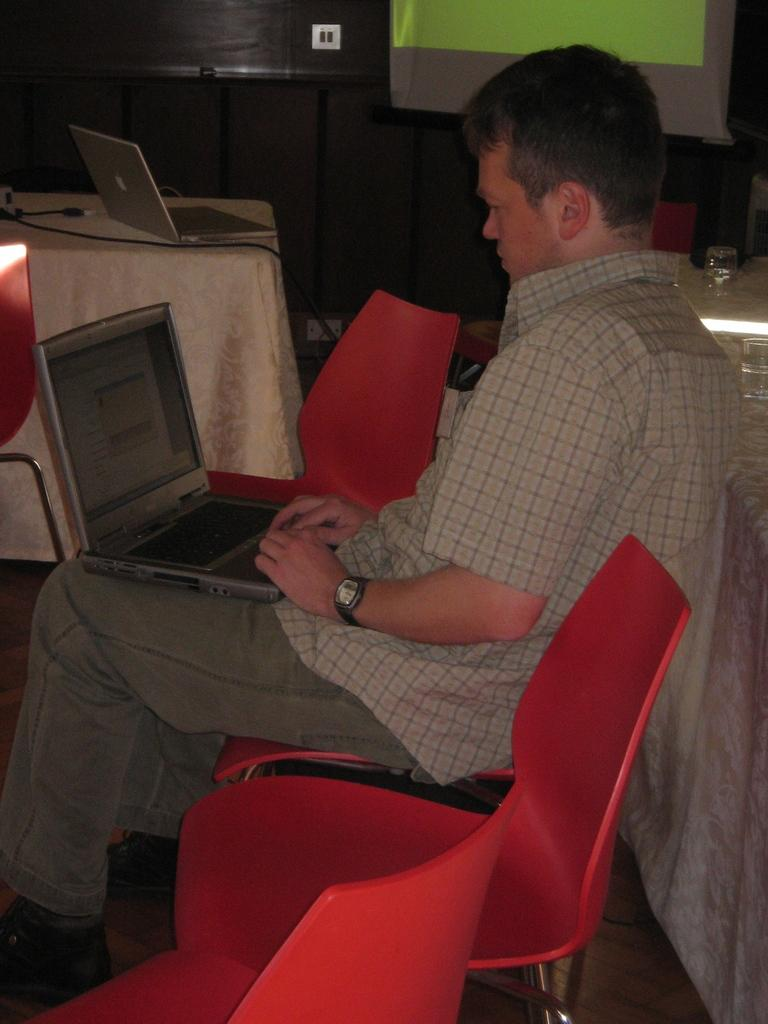Who is the person in the image? There is a man in the image. What is the man doing in the image? The man is sitting on a chair and operating a laptop. What else can be seen in the room besides the man? There are tables present in the room. Where is the laptop located when the man is not using it? There is a laptop present on a table. What type of powder can be seen falling from the ceiling in the image? There is no powder falling from the ceiling in the image. 